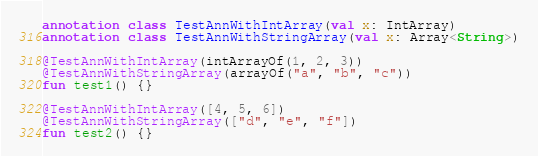<code> <loc_0><loc_0><loc_500><loc_500><_Kotlin_>annotation class TestAnnWithIntArray(val x: IntArray)
annotation class TestAnnWithStringArray(val x: Array<String>)

@TestAnnWithIntArray(intArrayOf(1, 2, 3))
@TestAnnWithStringArray(arrayOf("a", "b", "c"))
fun test1() {}

@TestAnnWithIntArray([4, 5, 6])
@TestAnnWithStringArray(["d", "e", "f"])
fun test2() {}</code> 